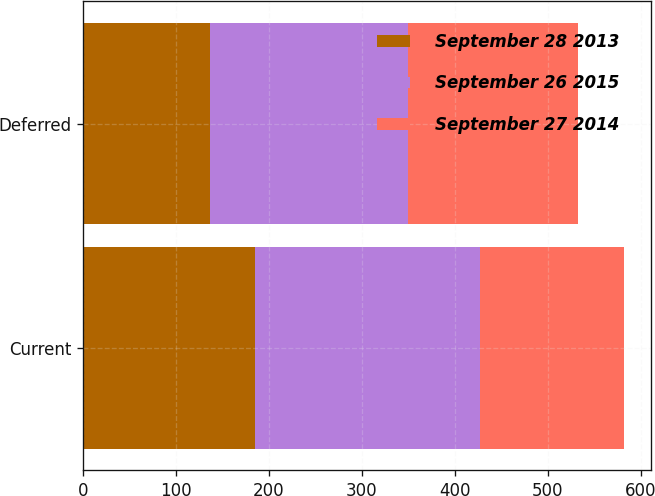<chart> <loc_0><loc_0><loc_500><loc_500><stacked_bar_chart><ecel><fcel>Current<fcel>Deferred<nl><fcel>September 28 2013<fcel>185.2<fcel>137<nl><fcel>September 26 2015<fcel>242.2<fcel>212.5<nl><fcel>September 27 2014<fcel>154.9<fcel>182.7<nl></chart> 